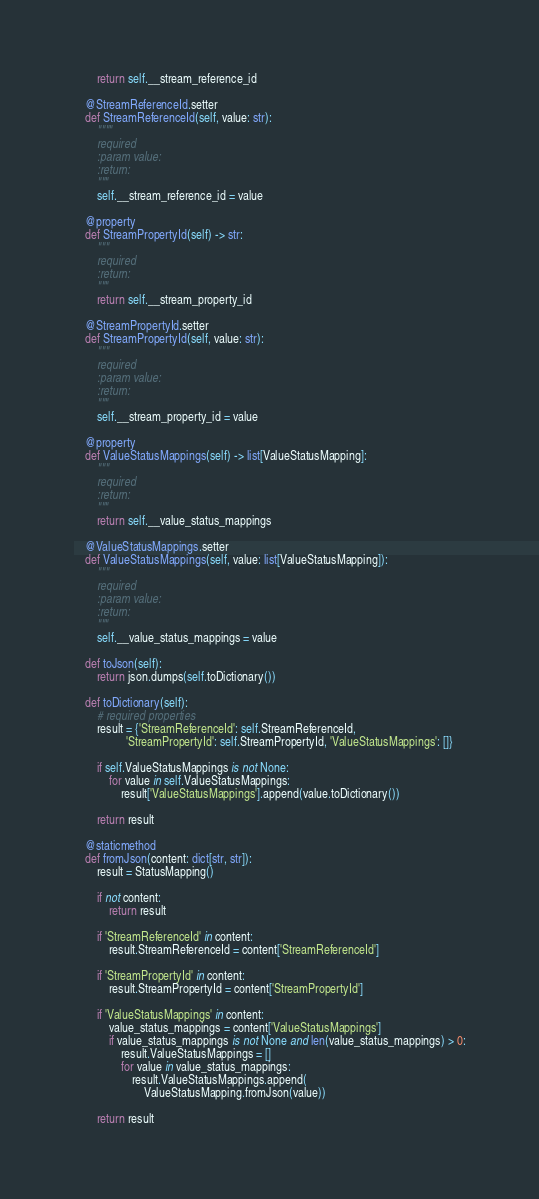Convert code to text. <code><loc_0><loc_0><loc_500><loc_500><_Python_>        return self.__stream_reference_id

    @StreamReferenceId.setter
    def StreamReferenceId(self, value: str):
        """"
        required
        :param value:
        :return:
        """
        self.__stream_reference_id = value

    @property
    def StreamPropertyId(self) -> str:
        """
        required
        :return:
        """
        return self.__stream_property_id

    @StreamPropertyId.setter
    def StreamPropertyId(self, value: str):
        """
        required
        :param value:
        :return:
        """
        self.__stream_property_id = value

    @property
    def ValueStatusMappings(self) -> list[ValueStatusMapping]:
        """
        required
        :return:
        """
        return self.__value_status_mappings

    @ValueStatusMappings.setter
    def ValueStatusMappings(self, value: list[ValueStatusMapping]):
        """
        required
        :param value:
        :return:
        """
        self.__value_status_mappings = value

    def toJson(self):
        return json.dumps(self.toDictionary())

    def toDictionary(self):
        # required properties
        result = {'StreamReferenceId': self.StreamReferenceId,
                  'StreamPropertyId': self.StreamPropertyId, 'ValueStatusMappings': []}

        if self.ValueStatusMappings is not None:
            for value in self.ValueStatusMappings:
                result['ValueStatusMappings'].append(value.toDictionary())

        return result

    @staticmethod
    def fromJson(content: dict[str, str]):
        result = StatusMapping()

        if not content:
            return result

        if 'StreamReferenceId' in content:
            result.StreamReferenceId = content['StreamReferenceId']

        if 'StreamPropertyId' in content:
            result.StreamPropertyId = content['StreamPropertyId']

        if 'ValueStatusMappings' in content:
            value_status_mappings = content['ValueStatusMappings']
            if value_status_mappings is not None and len(value_status_mappings) > 0:
                result.ValueStatusMappings = []
                for value in value_status_mappings:
                    result.ValueStatusMappings.append(
                        ValueStatusMapping.fromJson(value))

        return result
</code> 